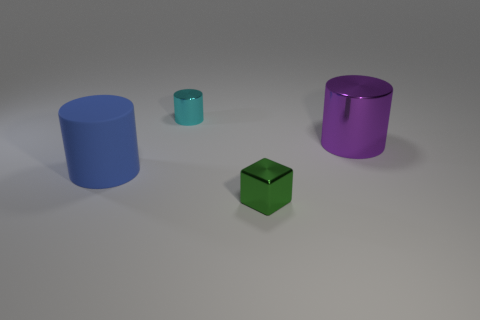Could you describe the colors of the objects in the image? Certainly! The image features objects in various colors: the cylinder on the far left is a vivid blue, the smaller item in front is teal, and the cube is a rich green. Finally, the cylinder on the right exhibits a deep purple hue. 